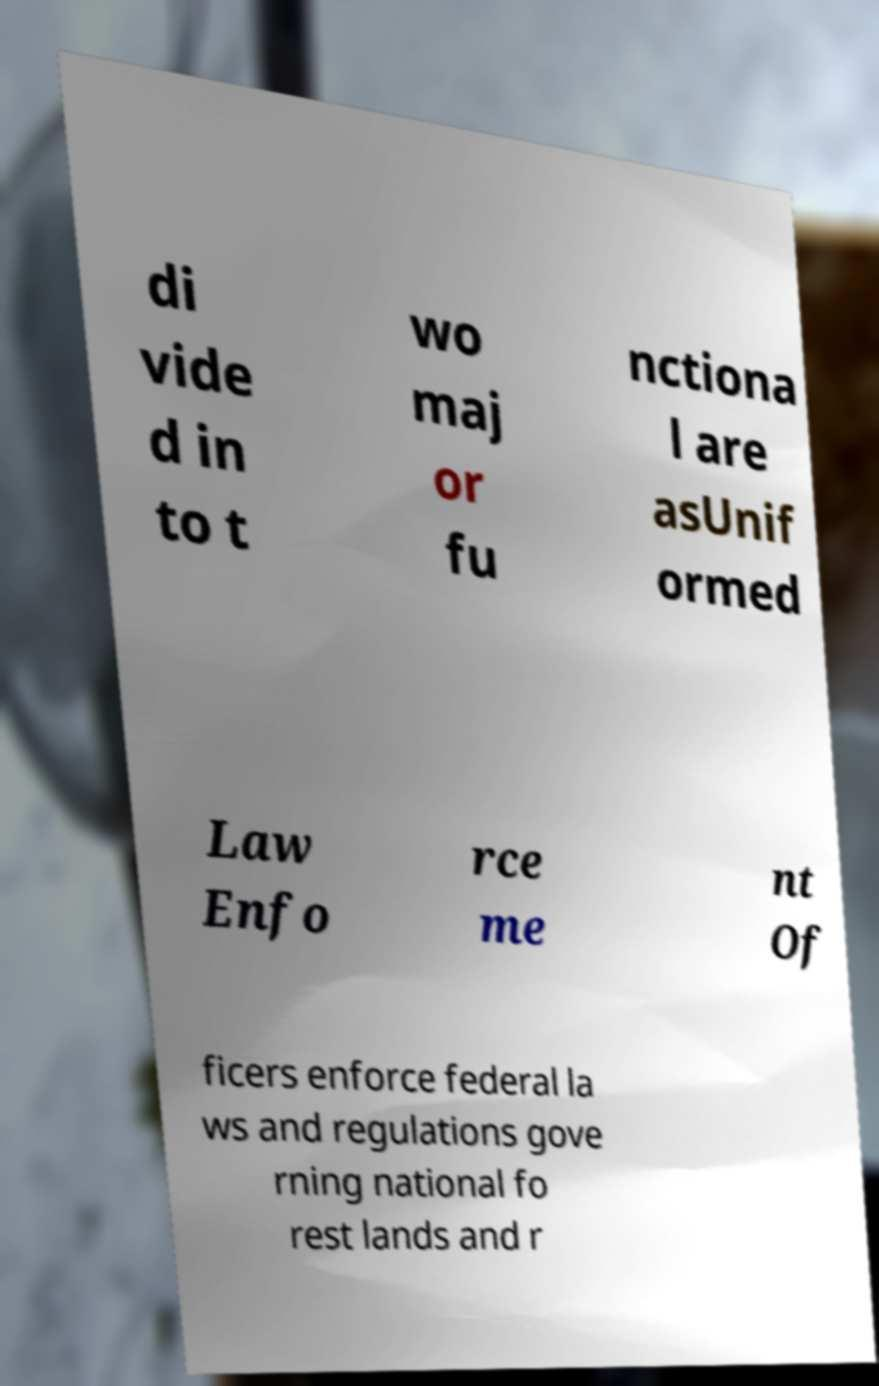I need the written content from this picture converted into text. Can you do that? di vide d in to t wo maj or fu nctiona l are asUnif ormed Law Enfo rce me nt Of ficers enforce federal la ws and regulations gove rning national fo rest lands and r 